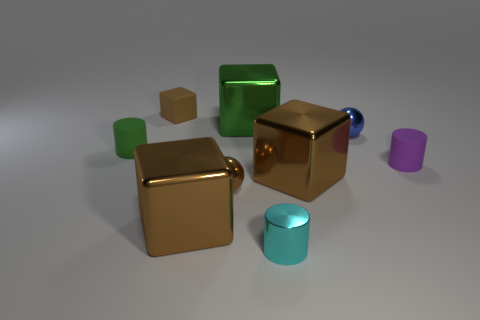Subtract all shiny cylinders. How many cylinders are left? 2 Subtract all brown spheres. How many brown cubes are left? 3 Add 1 large purple cylinders. How many objects exist? 10 Subtract all brown spheres. How many spheres are left? 1 Subtract all cyan cylinders. Subtract all gray balls. How many cylinders are left? 2 Subtract all cubes. How many objects are left? 5 Subtract 0 purple blocks. How many objects are left? 9 Subtract all big yellow rubber things. Subtract all brown matte cubes. How many objects are left? 8 Add 3 small blocks. How many small blocks are left? 4 Add 8 small cyan metallic cylinders. How many small cyan metallic cylinders exist? 9 